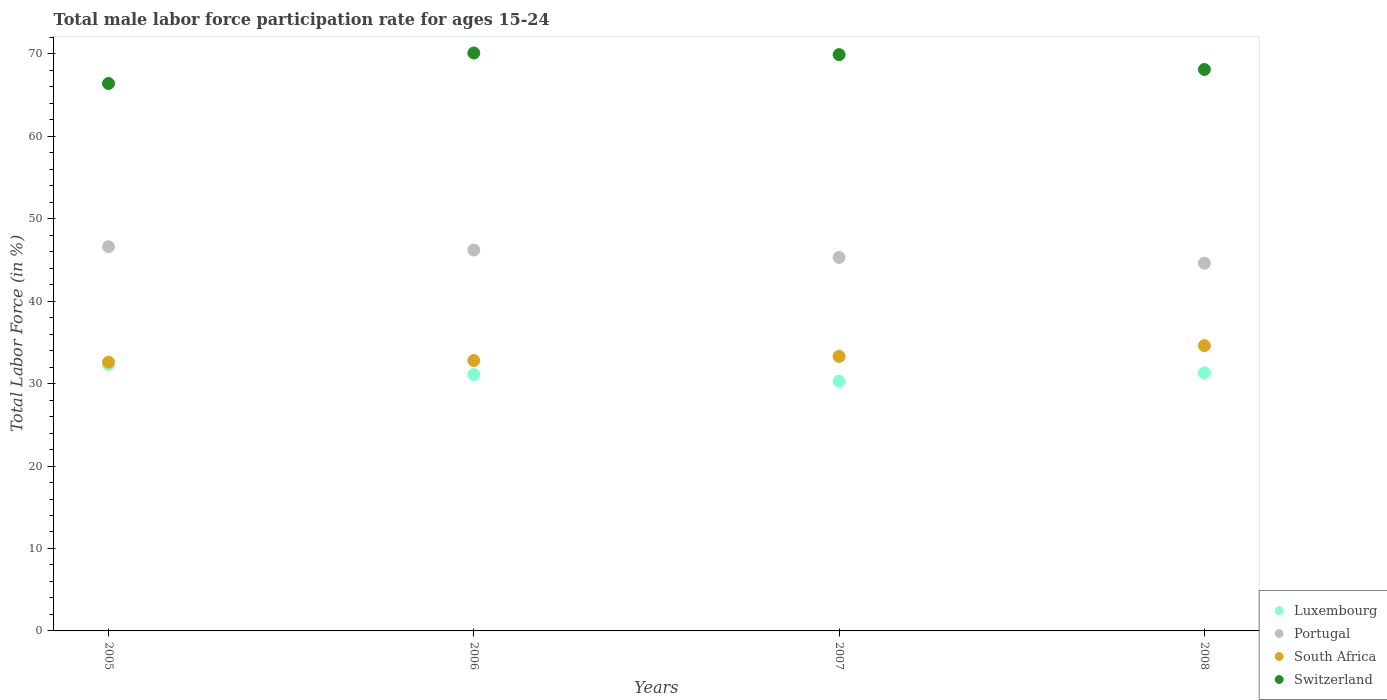What is the male labor force participation rate in South Africa in 2007?
Provide a short and direct response. 33.3. Across all years, what is the maximum male labor force participation rate in Luxembourg?
Offer a very short reply. 32.3. Across all years, what is the minimum male labor force participation rate in Luxembourg?
Your answer should be compact. 30.3. What is the total male labor force participation rate in Luxembourg in the graph?
Offer a very short reply. 125. What is the difference between the male labor force participation rate in South Africa in 2005 and that in 2007?
Provide a short and direct response. -0.7. What is the difference between the male labor force participation rate in Switzerland in 2006 and the male labor force participation rate in Portugal in 2008?
Make the answer very short. 25.5. What is the average male labor force participation rate in Luxembourg per year?
Provide a succinct answer. 31.25. In the year 2005, what is the difference between the male labor force participation rate in Switzerland and male labor force participation rate in Luxembourg?
Your answer should be very brief. 34.1. What is the ratio of the male labor force participation rate in South Africa in 2005 to that in 2007?
Provide a short and direct response. 0.98. What is the difference between the highest and the second highest male labor force participation rate in Luxembourg?
Offer a very short reply. 1. What is the difference between the highest and the lowest male labor force participation rate in Portugal?
Your answer should be compact. 2. Does the male labor force participation rate in Luxembourg monotonically increase over the years?
Provide a succinct answer. No. How many dotlines are there?
Your answer should be compact. 4. How many years are there in the graph?
Give a very brief answer. 4. What is the difference between two consecutive major ticks on the Y-axis?
Your response must be concise. 10. Are the values on the major ticks of Y-axis written in scientific E-notation?
Your answer should be very brief. No. Does the graph contain any zero values?
Offer a very short reply. No. How many legend labels are there?
Offer a very short reply. 4. What is the title of the graph?
Your response must be concise. Total male labor force participation rate for ages 15-24. Does "Cyprus" appear as one of the legend labels in the graph?
Ensure brevity in your answer.  No. What is the label or title of the Y-axis?
Ensure brevity in your answer.  Total Labor Force (in %). What is the Total Labor Force (in %) in Luxembourg in 2005?
Provide a short and direct response. 32.3. What is the Total Labor Force (in %) in Portugal in 2005?
Your response must be concise. 46.6. What is the Total Labor Force (in %) of South Africa in 2005?
Provide a short and direct response. 32.6. What is the Total Labor Force (in %) in Switzerland in 2005?
Your answer should be compact. 66.4. What is the Total Labor Force (in %) in Luxembourg in 2006?
Make the answer very short. 31.1. What is the Total Labor Force (in %) in Portugal in 2006?
Offer a very short reply. 46.2. What is the Total Labor Force (in %) in South Africa in 2006?
Your answer should be compact. 32.8. What is the Total Labor Force (in %) of Switzerland in 2006?
Provide a succinct answer. 70.1. What is the Total Labor Force (in %) in Luxembourg in 2007?
Give a very brief answer. 30.3. What is the Total Labor Force (in %) in Portugal in 2007?
Ensure brevity in your answer.  45.3. What is the Total Labor Force (in %) in South Africa in 2007?
Your answer should be very brief. 33.3. What is the Total Labor Force (in %) of Switzerland in 2007?
Offer a very short reply. 69.9. What is the Total Labor Force (in %) in Luxembourg in 2008?
Offer a very short reply. 31.3. What is the Total Labor Force (in %) of Portugal in 2008?
Offer a very short reply. 44.6. What is the Total Labor Force (in %) in South Africa in 2008?
Keep it short and to the point. 34.6. What is the Total Labor Force (in %) in Switzerland in 2008?
Make the answer very short. 68.1. Across all years, what is the maximum Total Labor Force (in %) in Luxembourg?
Provide a short and direct response. 32.3. Across all years, what is the maximum Total Labor Force (in %) in Portugal?
Your answer should be compact. 46.6. Across all years, what is the maximum Total Labor Force (in %) in South Africa?
Your answer should be compact. 34.6. Across all years, what is the maximum Total Labor Force (in %) in Switzerland?
Give a very brief answer. 70.1. Across all years, what is the minimum Total Labor Force (in %) of Luxembourg?
Give a very brief answer. 30.3. Across all years, what is the minimum Total Labor Force (in %) in Portugal?
Your answer should be very brief. 44.6. Across all years, what is the minimum Total Labor Force (in %) of South Africa?
Provide a short and direct response. 32.6. Across all years, what is the minimum Total Labor Force (in %) of Switzerland?
Your answer should be compact. 66.4. What is the total Total Labor Force (in %) of Luxembourg in the graph?
Make the answer very short. 125. What is the total Total Labor Force (in %) in Portugal in the graph?
Your answer should be compact. 182.7. What is the total Total Labor Force (in %) in South Africa in the graph?
Offer a terse response. 133.3. What is the total Total Labor Force (in %) of Switzerland in the graph?
Your response must be concise. 274.5. What is the difference between the Total Labor Force (in %) in Luxembourg in 2005 and that in 2006?
Ensure brevity in your answer.  1.2. What is the difference between the Total Labor Force (in %) of Portugal in 2005 and that in 2007?
Keep it short and to the point. 1.3. What is the difference between the Total Labor Force (in %) in South Africa in 2005 and that in 2007?
Provide a succinct answer. -0.7. What is the difference between the Total Labor Force (in %) in Switzerland in 2005 and that in 2007?
Your response must be concise. -3.5. What is the difference between the Total Labor Force (in %) of Luxembourg in 2005 and that in 2008?
Your response must be concise. 1. What is the difference between the Total Labor Force (in %) in Portugal in 2005 and that in 2008?
Offer a terse response. 2. What is the difference between the Total Labor Force (in %) of South Africa in 2005 and that in 2008?
Your answer should be very brief. -2. What is the difference between the Total Labor Force (in %) in Luxembourg in 2006 and that in 2007?
Make the answer very short. 0.8. What is the difference between the Total Labor Force (in %) in Portugal in 2006 and that in 2007?
Keep it short and to the point. 0.9. What is the difference between the Total Labor Force (in %) in South Africa in 2006 and that in 2007?
Your response must be concise. -0.5. What is the difference between the Total Labor Force (in %) in Switzerland in 2006 and that in 2007?
Keep it short and to the point. 0.2. What is the difference between the Total Labor Force (in %) in South Africa in 2007 and that in 2008?
Ensure brevity in your answer.  -1.3. What is the difference between the Total Labor Force (in %) in Switzerland in 2007 and that in 2008?
Provide a short and direct response. 1.8. What is the difference between the Total Labor Force (in %) in Luxembourg in 2005 and the Total Labor Force (in %) in Switzerland in 2006?
Provide a succinct answer. -37.8. What is the difference between the Total Labor Force (in %) of Portugal in 2005 and the Total Labor Force (in %) of Switzerland in 2006?
Your answer should be compact. -23.5. What is the difference between the Total Labor Force (in %) in South Africa in 2005 and the Total Labor Force (in %) in Switzerland in 2006?
Your answer should be compact. -37.5. What is the difference between the Total Labor Force (in %) in Luxembourg in 2005 and the Total Labor Force (in %) in Portugal in 2007?
Give a very brief answer. -13. What is the difference between the Total Labor Force (in %) of Luxembourg in 2005 and the Total Labor Force (in %) of Switzerland in 2007?
Ensure brevity in your answer.  -37.6. What is the difference between the Total Labor Force (in %) of Portugal in 2005 and the Total Labor Force (in %) of South Africa in 2007?
Your answer should be very brief. 13.3. What is the difference between the Total Labor Force (in %) of Portugal in 2005 and the Total Labor Force (in %) of Switzerland in 2007?
Keep it short and to the point. -23.3. What is the difference between the Total Labor Force (in %) in South Africa in 2005 and the Total Labor Force (in %) in Switzerland in 2007?
Give a very brief answer. -37.3. What is the difference between the Total Labor Force (in %) of Luxembourg in 2005 and the Total Labor Force (in %) of South Africa in 2008?
Offer a very short reply. -2.3. What is the difference between the Total Labor Force (in %) of Luxembourg in 2005 and the Total Labor Force (in %) of Switzerland in 2008?
Offer a terse response. -35.8. What is the difference between the Total Labor Force (in %) in Portugal in 2005 and the Total Labor Force (in %) in South Africa in 2008?
Make the answer very short. 12. What is the difference between the Total Labor Force (in %) of Portugal in 2005 and the Total Labor Force (in %) of Switzerland in 2008?
Offer a terse response. -21.5. What is the difference between the Total Labor Force (in %) of South Africa in 2005 and the Total Labor Force (in %) of Switzerland in 2008?
Provide a succinct answer. -35.5. What is the difference between the Total Labor Force (in %) in Luxembourg in 2006 and the Total Labor Force (in %) in Switzerland in 2007?
Ensure brevity in your answer.  -38.8. What is the difference between the Total Labor Force (in %) of Portugal in 2006 and the Total Labor Force (in %) of South Africa in 2007?
Provide a succinct answer. 12.9. What is the difference between the Total Labor Force (in %) in Portugal in 2006 and the Total Labor Force (in %) in Switzerland in 2007?
Your answer should be very brief. -23.7. What is the difference between the Total Labor Force (in %) in South Africa in 2006 and the Total Labor Force (in %) in Switzerland in 2007?
Give a very brief answer. -37.1. What is the difference between the Total Labor Force (in %) in Luxembourg in 2006 and the Total Labor Force (in %) in Portugal in 2008?
Offer a very short reply. -13.5. What is the difference between the Total Labor Force (in %) of Luxembourg in 2006 and the Total Labor Force (in %) of South Africa in 2008?
Your answer should be very brief. -3.5. What is the difference between the Total Labor Force (in %) in Luxembourg in 2006 and the Total Labor Force (in %) in Switzerland in 2008?
Offer a very short reply. -37. What is the difference between the Total Labor Force (in %) in Portugal in 2006 and the Total Labor Force (in %) in South Africa in 2008?
Provide a succinct answer. 11.6. What is the difference between the Total Labor Force (in %) in Portugal in 2006 and the Total Labor Force (in %) in Switzerland in 2008?
Your answer should be very brief. -21.9. What is the difference between the Total Labor Force (in %) of South Africa in 2006 and the Total Labor Force (in %) of Switzerland in 2008?
Keep it short and to the point. -35.3. What is the difference between the Total Labor Force (in %) in Luxembourg in 2007 and the Total Labor Force (in %) in Portugal in 2008?
Provide a succinct answer. -14.3. What is the difference between the Total Labor Force (in %) in Luxembourg in 2007 and the Total Labor Force (in %) in Switzerland in 2008?
Provide a short and direct response. -37.8. What is the difference between the Total Labor Force (in %) in Portugal in 2007 and the Total Labor Force (in %) in South Africa in 2008?
Offer a very short reply. 10.7. What is the difference between the Total Labor Force (in %) in Portugal in 2007 and the Total Labor Force (in %) in Switzerland in 2008?
Your response must be concise. -22.8. What is the difference between the Total Labor Force (in %) in South Africa in 2007 and the Total Labor Force (in %) in Switzerland in 2008?
Your answer should be compact. -34.8. What is the average Total Labor Force (in %) of Luxembourg per year?
Provide a short and direct response. 31.25. What is the average Total Labor Force (in %) in Portugal per year?
Your response must be concise. 45.67. What is the average Total Labor Force (in %) of South Africa per year?
Give a very brief answer. 33.33. What is the average Total Labor Force (in %) of Switzerland per year?
Provide a short and direct response. 68.62. In the year 2005, what is the difference between the Total Labor Force (in %) of Luxembourg and Total Labor Force (in %) of Portugal?
Offer a terse response. -14.3. In the year 2005, what is the difference between the Total Labor Force (in %) in Luxembourg and Total Labor Force (in %) in Switzerland?
Provide a short and direct response. -34.1. In the year 2005, what is the difference between the Total Labor Force (in %) in Portugal and Total Labor Force (in %) in Switzerland?
Provide a succinct answer. -19.8. In the year 2005, what is the difference between the Total Labor Force (in %) in South Africa and Total Labor Force (in %) in Switzerland?
Give a very brief answer. -33.8. In the year 2006, what is the difference between the Total Labor Force (in %) in Luxembourg and Total Labor Force (in %) in Portugal?
Keep it short and to the point. -15.1. In the year 2006, what is the difference between the Total Labor Force (in %) of Luxembourg and Total Labor Force (in %) of Switzerland?
Your response must be concise. -39. In the year 2006, what is the difference between the Total Labor Force (in %) in Portugal and Total Labor Force (in %) in South Africa?
Your response must be concise. 13.4. In the year 2006, what is the difference between the Total Labor Force (in %) of Portugal and Total Labor Force (in %) of Switzerland?
Your response must be concise. -23.9. In the year 2006, what is the difference between the Total Labor Force (in %) in South Africa and Total Labor Force (in %) in Switzerland?
Offer a terse response. -37.3. In the year 2007, what is the difference between the Total Labor Force (in %) in Luxembourg and Total Labor Force (in %) in Portugal?
Keep it short and to the point. -15. In the year 2007, what is the difference between the Total Labor Force (in %) in Luxembourg and Total Labor Force (in %) in Switzerland?
Ensure brevity in your answer.  -39.6. In the year 2007, what is the difference between the Total Labor Force (in %) in Portugal and Total Labor Force (in %) in Switzerland?
Provide a succinct answer. -24.6. In the year 2007, what is the difference between the Total Labor Force (in %) in South Africa and Total Labor Force (in %) in Switzerland?
Your response must be concise. -36.6. In the year 2008, what is the difference between the Total Labor Force (in %) of Luxembourg and Total Labor Force (in %) of Switzerland?
Offer a very short reply. -36.8. In the year 2008, what is the difference between the Total Labor Force (in %) in Portugal and Total Labor Force (in %) in Switzerland?
Your answer should be compact. -23.5. In the year 2008, what is the difference between the Total Labor Force (in %) of South Africa and Total Labor Force (in %) of Switzerland?
Keep it short and to the point. -33.5. What is the ratio of the Total Labor Force (in %) of Luxembourg in 2005 to that in 2006?
Ensure brevity in your answer.  1.04. What is the ratio of the Total Labor Force (in %) of Portugal in 2005 to that in 2006?
Offer a terse response. 1.01. What is the ratio of the Total Labor Force (in %) in Switzerland in 2005 to that in 2006?
Make the answer very short. 0.95. What is the ratio of the Total Labor Force (in %) in Luxembourg in 2005 to that in 2007?
Make the answer very short. 1.07. What is the ratio of the Total Labor Force (in %) of Portugal in 2005 to that in 2007?
Your answer should be very brief. 1.03. What is the ratio of the Total Labor Force (in %) in South Africa in 2005 to that in 2007?
Give a very brief answer. 0.98. What is the ratio of the Total Labor Force (in %) of Switzerland in 2005 to that in 2007?
Provide a short and direct response. 0.95. What is the ratio of the Total Labor Force (in %) in Luxembourg in 2005 to that in 2008?
Provide a succinct answer. 1.03. What is the ratio of the Total Labor Force (in %) in Portugal in 2005 to that in 2008?
Provide a succinct answer. 1.04. What is the ratio of the Total Labor Force (in %) in South Africa in 2005 to that in 2008?
Ensure brevity in your answer.  0.94. What is the ratio of the Total Labor Force (in %) of Luxembourg in 2006 to that in 2007?
Keep it short and to the point. 1.03. What is the ratio of the Total Labor Force (in %) of Portugal in 2006 to that in 2007?
Your response must be concise. 1.02. What is the ratio of the Total Labor Force (in %) in Luxembourg in 2006 to that in 2008?
Your answer should be compact. 0.99. What is the ratio of the Total Labor Force (in %) of Portugal in 2006 to that in 2008?
Your response must be concise. 1.04. What is the ratio of the Total Labor Force (in %) in South Africa in 2006 to that in 2008?
Ensure brevity in your answer.  0.95. What is the ratio of the Total Labor Force (in %) of Switzerland in 2006 to that in 2008?
Offer a terse response. 1.03. What is the ratio of the Total Labor Force (in %) in Luxembourg in 2007 to that in 2008?
Give a very brief answer. 0.97. What is the ratio of the Total Labor Force (in %) in Portugal in 2007 to that in 2008?
Offer a terse response. 1.02. What is the ratio of the Total Labor Force (in %) of South Africa in 2007 to that in 2008?
Keep it short and to the point. 0.96. What is the ratio of the Total Labor Force (in %) in Switzerland in 2007 to that in 2008?
Keep it short and to the point. 1.03. What is the difference between the highest and the second highest Total Labor Force (in %) in Luxembourg?
Offer a terse response. 1. What is the difference between the highest and the second highest Total Labor Force (in %) in South Africa?
Make the answer very short. 1.3. What is the difference between the highest and the second highest Total Labor Force (in %) in Switzerland?
Offer a very short reply. 0.2. What is the difference between the highest and the lowest Total Labor Force (in %) of Switzerland?
Provide a short and direct response. 3.7. 